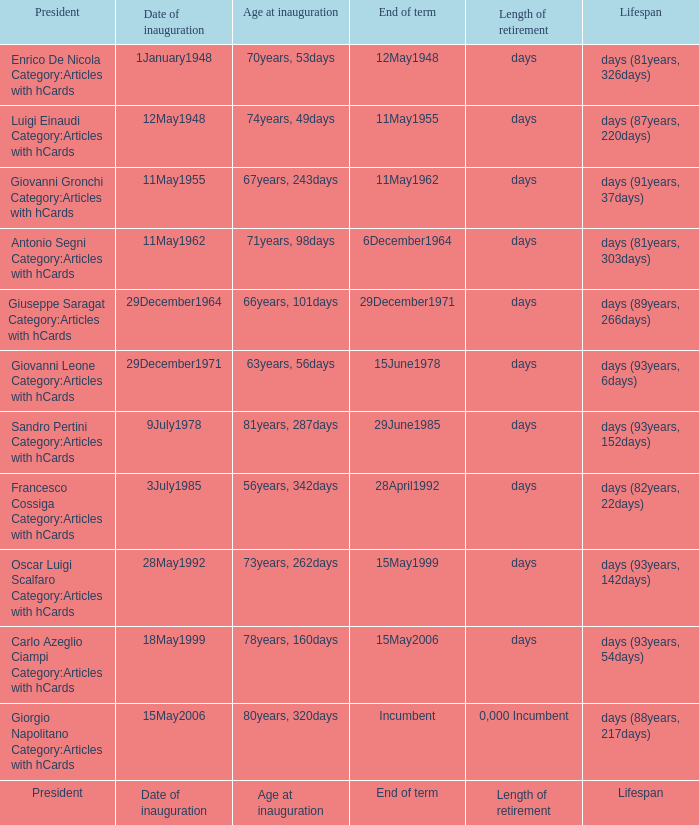What is the Length of retirement of the President with an Age at inauguration of 70years, 53days? Days. 